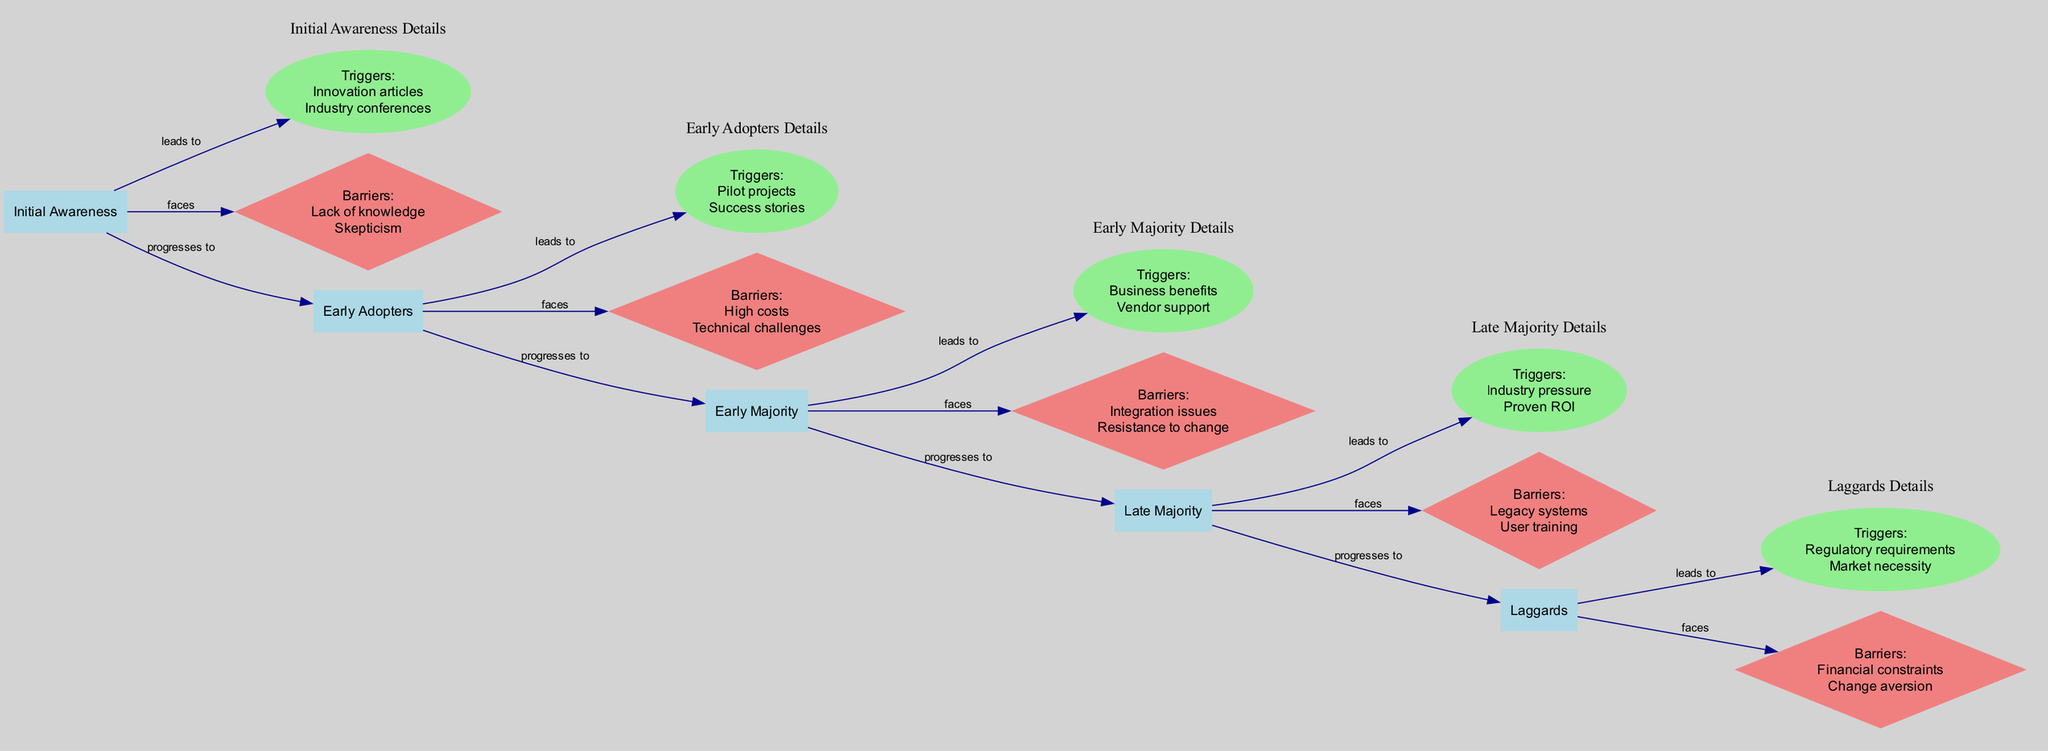What stage comes after "Early Adopters"? The diagram shows a linear progression of stages in the Adoption Cycle. After "Early Adopters," the next stage is "Early Majority."
Answer: Early Majority How many key barriers are listed for the "Late Majority" stage? By examining the "Late Majority" section in the diagram, it shows two barriers listed: "Legacy systems" and "User training." Therefore, the answer is two.
Answer: Two Which communication type is directed from "Sales" to "Marketing"? In the communication flow, there is an arrow from "Sales" to "Marketing" labelled as "Feedback Loop." Thus, the communication type is "Feedback Loop."
Answer: Feedback Loop What is the strength of influence of "Industry Expert"? The diagram indicates that the "Industry Expert" has a "High" strength of influence over "Early Adopters" and "Early Majority."
Answer: High What are two triggers identified in the "Laggards" stage? Referring to the "Laggards" stage, the identified triggers are "Regulatory requirements" and "Market necessity." Therefore, the two triggers are those listed.
Answer: Regulatory requirements, Market necessity What impact does business automation have on employee productivity? The diagram shows the impact on employee productivity as "Increased efficiency" and "Improved quality," indicating positive effects.
Answer: Increased efficiency, Improved quality At which stage are "Pilot projects" considered a key trigger? Looking at the various stages, "Pilot projects" are highlighted as a key trigger specifically in the "Early Adopters" stage.
Answer: Early Adopters How many total stages are represented in the diagram? The diagram presents five distinct stages in the Adoption Cycle of Machine Learning Technologies, namely: Initial Awareness, Early Adopters, Early Majority, Late Majority, and Laggards. Thus, the total number is five.
Answer: Five Which department communicates "Product Updates" to "Marketing"? According to the communication flow detailed in the diagram, "Product Development" is responsible for communicating "Product Updates" to "Marketing."
Answer: Product Development 